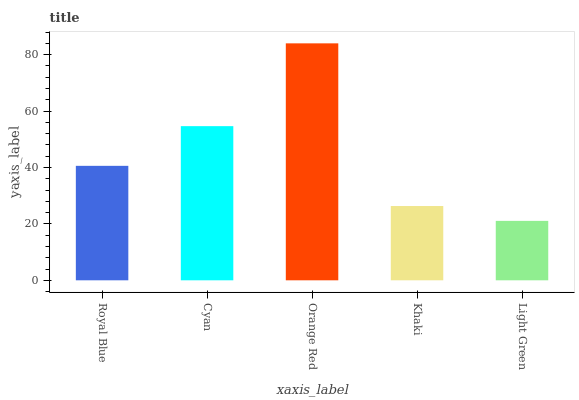Is Cyan the minimum?
Answer yes or no. No. Is Cyan the maximum?
Answer yes or no. No. Is Cyan greater than Royal Blue?
Answer yes or no. Yes. Is Royal Blue less than Cyan?
Answer yes or no. Yes. Is Royal Blue greater than Cyan?
Answer yes or no. No. Is Cyan less than Royal Blue?
Answer yes or no. No. Is Royal Blue the high median?
Answer yes or no. Yes. Is Royal Blue the low median?
Answer yes or no. Yes. Is Cyan the high median?
Answer yes or no. No. Is Khaki the low median?
Answer yes or no. No. 